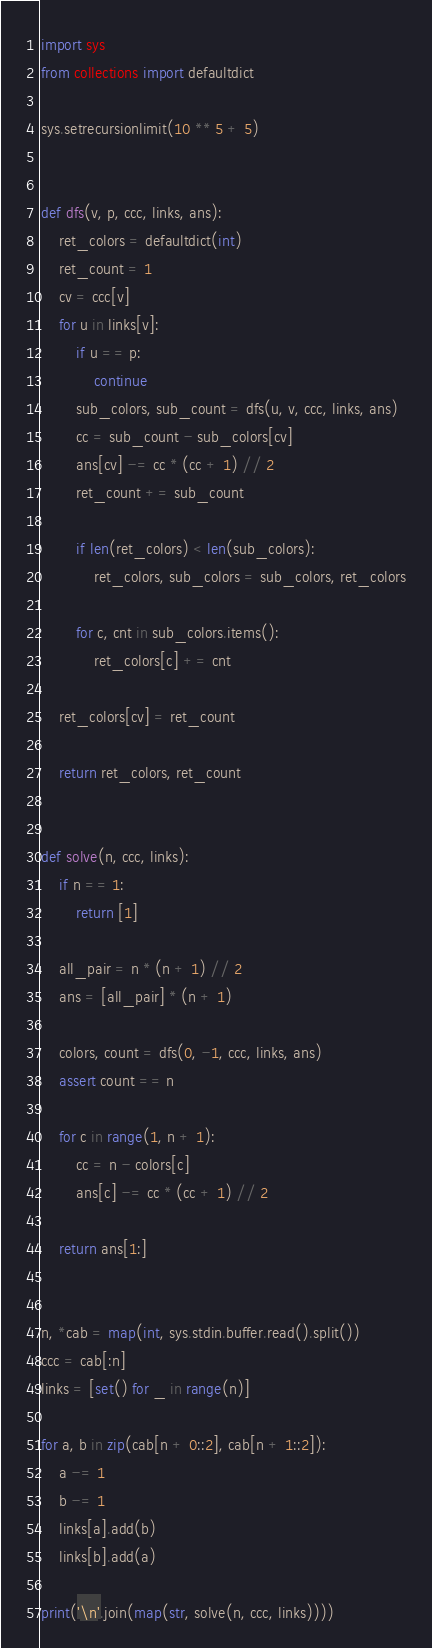<code> <loc_0><loc_0><loc_500><loc_500><_Python_>import sys
from collections import defaultdict

sys.setrecursionlimit(10 ** 5 + 5)


def dfs(v, p, ccc, links, ans):
    ret_colors = defaultdict(int)
    ret_count = 1
    cv = ccc[v]
    for u in links[v]:
        if u == p:
            continue
        sub_colors, sub_count = dfs(u, v, ccc, links, ans)
        cc = sub_count - sub_colors[cv]
        ans[cv] -= cc * (cc + 1) // 2
        ret_count += sub_count

        if len(ret_colors) < len(sub_colors):
            ret_colors, sub_colors = sub_colors, ret_colors

        for c, cnt in sub_colors.items():
            ret_colors[c] += cnt

    ret_colors[cv] = ret_count

    return ret_colors, ret_count


def solve(n, ccc, links):
    if n == 1:
        return [1]

    all_pair = n * (n + 1) // 2
    ans = [all_pair] * (n + 1)

    colors, count = dfs(0, -1, ccc, links, ans)
    assert count == n

    for c in range(1, n + 1):
        cc = n - colors[c]
        ans[c] -= cc * (cc + 1) // 2

    return ans[1:]


n, *cab = map(int, sys.stdin.buffer.read().split())
ccc = cab[:n]
links = [set() for _ in range(n)]

for a, b in zip(cab[n + 0::2], cab[n + 1::2]):
    a -= 1
    b -= 1
    links[a].add(b)
    links[b].add(a)

print('\n'.join(map(str, solve(n, ccc, links))))
</code> 